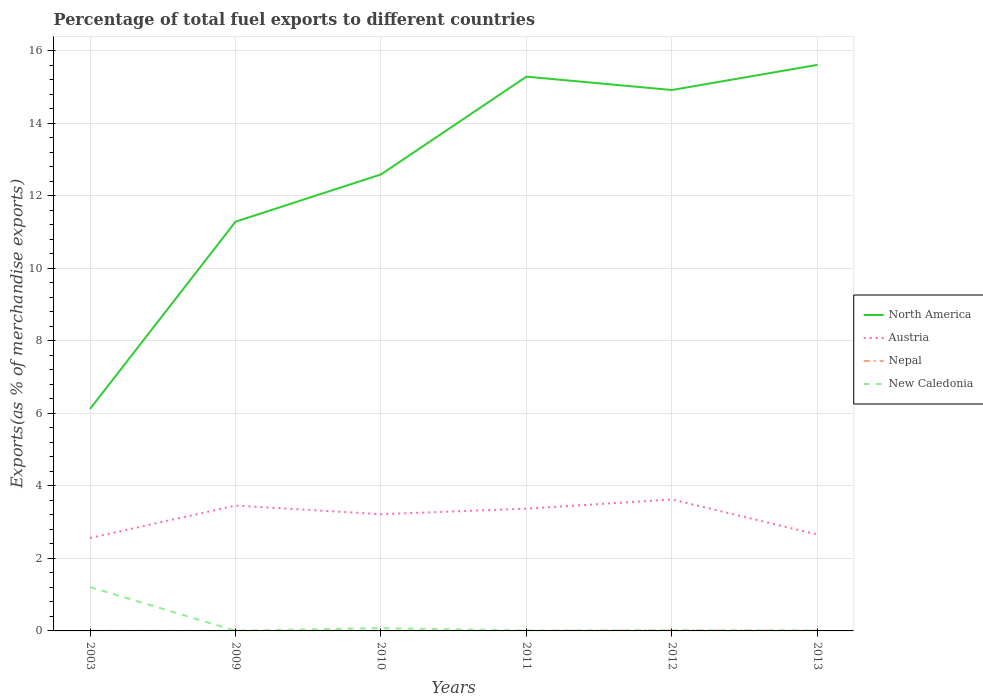How many different coloured lines are there?
Offer a terse response. 4. Across all years, what is the maximum percentage of exports to different countries in New Caledonia?
Provide a succinct answer. 0. What is the total percentage of exports to different countries in Nepal in the graph?
Give a very brief answer. -0. What is the difference between the highest and the second highest percentage of exports to different countries in Austria?
Keep it short and to the point. 1.06. What is the difference between the highest and the lowest percentage of exports to different countries in New Caledonia?
Ensure brevity in your answer.  1. Is the percentage of exports to different countries in New Caledonia strictly greater than the percentage of exports to different countries in North America over the years?
Your answer should be very brief. Yes. How many lines are there?
Keep it short and to the point. 4. How many years are there in the graph?
Give a very brief answer. 6. How many legend labels are there?
Provide a short and direct response. 4. How are the legend labels stacked?
Offer a very short reply. Vertical. What is the title of the graph?
Make the answer very short. Percentage of total fuel exports to different countries. Does "Switzerland" appear as one of the legend labels in the graph?
Your answer should be compact. No. What is the label or title of the Y-axis?
Your answer should be very brief. Exports(as % of merchandise exports). What is the Exports(as % of merchandise exports) in North America in 2003?
Your answer should be very brief. 6.12. What is the Exports(as % of merchandise exports) of Austria in 2003?
Keep it short and to the point. 2.56. What is the Exports(as % of merchandise exports) in Nepal in 2003?
Your response must be concise. 0. What is the Exports(as % of merchandise exports) in New Caledonia in 2003?
Keep it short and to the point. 1.21. What is the Exports(as % of merchandise exports) in North America in 2009?
Make the answer very short. 11.28. What is the Exports(as % of merchandise exports) of Austria in 2009?
Your answer should be very brief. 3.46. What is the Exports(as % of merchandise exports) in Nepal in 2009?
Provide a short and direct response. 0. What is the Exports(as % of merchandise exports) of New Caledonia in 2009?
Offer a very short reply. 0. What is the Exports(as % of merchandise exports) of North America in 2010?
Make the answer very short. 12.59. What is the Exports(as % of merchandise exports) of Austria in 2010?
Your answer should be very brief. 3.22. What is the Exports(as % of merchandise exports) of Nepal in 2010?
Ensure brevity in your answer.  4.5184108995034e-5. What is the Exports(as % of merchandise exports) in New Caledonia in 2010?
Your answer should be compact. 0.08. What is the Exports(as % of merchandise exports) in North America in 2011?
Your answer should be very brief. 15.28. What is the Exports(as % of merchandise exports) in Austria in 2011?
Make the answer very short. 3.37. What is the Exports(as % of merchandise exports) of Nepal in 2011?
Ensure brevity in your answer.  5.17830048737702e-6. What is the Exports(as % of merchandise exports) of New Caledonia in 2011?
Keep it short and to the point. 0.01. What is the Exports(as % of merchandise exports) in North America in 2012?
Keep it short and to the point. 14.92. What is the Exports(as % of merchandise exports) in Austria in 2012?
Your answer should be compact. 3.62. What is the Exports(as % of merchandise exports) of Nepal in 2012?
Your answer should be very brief. 0.01. What is the Exports(as % of merchandise exports) of New Caledonia in 2012?
Provide a short and direct response. 0.02. What is the Exports(as % of merchandise exports) of North America in 2013?
Ensure brevity in your answer.  15.61. What is the Exports(as % of merchandise exports) in Austria in 2013?
Offer a terse response. 2.66. What is the Exports(as % of merchandise exports) in Nepal in 2013?
Make the answer very short. 0. What is the Exports(as % of merchandise exports) in New Caledonia in 2013?
Make the answer very short. 0.01. Across all years, what is the maximum Exports(as % of merchandise exports) of North America?
Make the answer very short. 15.61. Across all years, what is the maximum Exports(as % of merchandise exports) in Austria?
Your response must be concise. 3.62. Across all years, what is the maximum Exports(as % of merchandise exports) in Nepal?
Keep it short and to the point. 0.01. Across all years, what is the maximum Exports(as % of merchandise exports) in New Caledonia?
Your answer should be compact. 1.21. Across all years, what is the minimum Exports(as % of merchandise exports) of North America?
Provide a succinct answer. 6.12. Across all years, what is the minimum Exports(as % of merchandise exports) in Austria?
Offer a very short reply. 2.56. Across all years, what is the minimum Exports(as % of merchandise exports) in Nepal?
Make the answer very short. 5.17830048737702e-6. Across all years, what is the minimum Exports(as % of merchandise exports) in New Caledonia?
Your answer should be compact. 0. What is the total Exports(as % of merchandise exports) of North America in the graph?
Your answer should be compact. 75.8. What is the total Exports(as % of merchandise exports) of Austria in the graph?
Your answer should be very brief. 18.89. What is the total Exports(as % of merchandise exports) of Nepal in the graph?
Provide a short and direct response. 0.02. What is the total Exports(as % of merchandise exports) in New Caledonia in the graph?
Make the answer very short. 1.33. What is the difference between the Exports(as % of merchandise exports) of North America in 2003 and that in 2009?
Provide a short and direct response. -5.16. What is the difference between the Exports(as % of merchandise exports) in Austria in 2003 and that in 2009?
Offer a very short reply. -0.89. What is the difference between the Exports(as % of merchandise exports) in Nepal in 2003 and that in 2009?
Offer a terse response. 0. What is the difference between the Exports(as % of merchandise exports) of New Caledonia in 2003 and that in 2009?
Your answer should be compact. 1.21. What is the difference between the Exports(as % of merchandise exports) of North America in 2003 and that in 2010?
Provide a short and direct response. -6.47. What is the difference between the Exports(as % of merchandise exports) in Austria in 2003 and that in 2010?
Your response must be concise. -0.66. What is the difference between the Exports(as % of merchandise exports) of Nepal in 2003 and that in 2010?
Your response must be concise. 0. What is the difference between the Exports(as % of merchandise exports) of New Caledonia in 2003 and that in 2010?
Provide a succinct answer. 1.13. What is the difference between the Exports(as % of merchandise exports) of North America in 2003 and that in 2011?
Offer a very short reply. -9.16. What is the difference between the Exports(as % of merchandise exports) of Austria in 2003 and that in 2011?
Your answer should be very brief. -0.81. What is the difference between the Exports(as % of merchandise exports) in Nepal in 2003 and that in 2011?
Your response must be concise. 0. What is the difference between the Exports(as % of merchandise exports) in New Caledonia in 2003 and that in 2011?
Keep it short and to the point. 1.2. What is the difference between the Exports(as % of merchandise exports) in North America in 2003 and that in 2012?
Offer a very short reply. -8.79. What is the difference between the Exports(as % of merchandise exports) in Austria in 2003 and that in 2012?
Your answer should be compact. -1.06. What is the difference between the Exports(as % of merchandise exports) of Nepal in 2003 and that in 2012?
Your response must be concise. -0.01. What is the difference between the Exports(as % of merchandise exports) in New Caledonia in 2003 and that in 2012?
Ensure brevity in your answer.  1.19. What is the difference between the Exports(as % of merchandise exports) of North America in 2003 and that in 2013?
Keep it short and to the point. -9.49. What is the difference between the Exports(as % of merchandise exports) of Austria in 2003 and that in 2013?
Make the answer very short. -0.1. What is the difference between the Exports(as % of merchandise exports) of Nepal in 2003 and that in 2013?
Your answer should be very brief. 0. What is the difference between the Exports(as % of merchandise exports) of New Caledonia in 2003 and that in 2013?
Your answer should be compact. 1.2. What is the difference between the Exports(as % of merchandise exports) of North America in 2009 and that in 2010?
Your answer should be very brief. -1.3. What is the difference between the Exports(as % of merchandise exports) in Austria in 2009 and that in 2010?
Give a very brief answer. 0.24. What is the difference between the Exports(as % of merchandise exports) in Nepal in 2009 and that in 2010?
Keep it short and to the point. 0. What is the difference between the Exports(as % of merchandise exports) of New Caledonia in 2009 and that in 2010?
Give a very brief answer. -0.07. What is the difference between the Exports(as % of merchandise exports) of North America in 2009 and that in 2011?
Offer a terse response. -4. What is the difference between the Exports(as % of merchandise exports) in Austria in 2009 and that in 2011?
Offer a terse response. 0.09. What is the difference between the Exports(as % of merchandise exports) of Nepal in 2009 and that in 2011?
Provide a succinct answer. 0. What is the difference between the Exports(as % of merchandise exports) in New Caledonia in 2009 and that in 2011?
Your response must be concise. -0.01. What is the difference between the Exports(as % of merchandise exports) of North America in 2009 and that in 2012?
Your answer should be compact. -3.63. What is the difference between the Exports(as % of merchandise exports) of Austria in 2009 and that in 2012?
Give a very brief answer. -0.17. What is the difference between the Exports(as % of merchandise exports) of Nepal in 2009 and that in 2012?
Offer a terse response. -0.01. What is the difference between the Exports(as % of merchandise exports) in New Caledonia in 2009 and that in 2012?
Provide a succinct answer. -0.01. What is the difference between the Exports(as % of merchandise exports) in North America in 2009 and that in 2013?
Keep it short and to the point. -4.32. What is the difference between the Exports(as % of merchandise exports) in Austria in 2009 and that in 2013?
Your response must be concise. 0.8. What is the difference between the Exports(as % of merchandise exports) of Nepal in 2009 and that in 2013?
Offer a terse response. -0. What is the difference between the Exports(as % of merchandise exports) of New Caledonia in 2009 and that in 2013?
Make the answer very short. -0.01. What is the difference between the Exports(as % of merchandise exports) in North America in 2010 and that in 2011?
Offer a terse response. -2.7. What is the difference between the Exports(as % of merchandise exports) of Austria in 2010 and that in 2011?
Provide a short and direct response. -0.15. What is the difference between the Exports(as % of merchandise exports) of New Caledonia in 2010 and that in 2011?
Your answer should be compact. 0.07. What is the difference between the Exports(as % of merchandise exports) of North America in 2010 and that in 2012?
Provide a short and direct response. -2.33. What is the difference between the Exports(as % of merchandise exports) in Austria in 2010 and that in 2012?
Offer a terse response. -0.41. What is the difference between the Exports(as % of merchandise exports) of Nepal in 2010 and that in 2012?
Provide a short and direct response. -0.01. What is the difference between the Exports(as % of merchandise exports) of New Caledonia in 2010 and that in 2012?
Provide a succinct answer. 0.06. What is the difference between the Exports(as % of merchandise exports) in North America in 2010 and that in 2013?
Your answer should be compact. -3.02. What is the difference between the Exports(as % of merchandise exports) of Austria in 2010 and that in 2013?
Offer a terse response. 0.56. What is the difference between the Exports(as % of merchandise exports) of Nepal in 2010 and that in 2013?
Ensure brevity in your answer.  -0. What is the difference between the Exports(as % of merchandise exports) in New Caledonia in 2010 and that in 2013?
Keep it short and to the point. 0.06. What is the difference between the Exports(as % of merchandise exports) in North America in 2011 and that in 2012?
Offer a terse response. 0.37. What is the difference between the Exports(as % of merchandise exports) in Austria in 2011 and that in 2012?
Your response must be concise. -0.25. What is the difference between the Exports(as % of merchandise exports) of Nepal in 2011 and that in 2012?
Make the answer very short. -0.01. What is the difference between the Exports(as % of merchandise exports) in New Caledonia in 2011 and that in 2012?
Offer a very short reply. -0. What is the difference between the Exports(as % of merchandise exports) of North America in 2011 and that in 2013?
Your response must be concise. -0.32. What is the difference between the Exports(as % of merchandise exports) of Austria in 2011 and that in 2013?
Your answer should be compact. 0.71. What is the difference between the Exports(as % of merchandise exports) in Nepal in 2011 and that in 2013?
Your answer should be very brief. -0. What is the difference between the Exports(as % of merchandise exports) of New Caledonia in 2011 and that in 2013?
Provide a short and direct response. -0. What is the difference between the Exports(as % of merchandise exports) in North America in 2012 and that in 2013?
Make the answer very short. -0.69. What is the difference between the Exports(as % of merchandise exports) of Austria in 2012 and that in 2013?
Keep it short and to the point. 0.97. What is the difference between the Exports(as % of merchandise exports) of Nepal in 2012 and that in 2013?
Keep it short and to the point. 0.01. What is the difference between the Exports(as % of merchandise exports) in New Caledonia in 2012 and that in 2013?
Keep it short and to the point. 0. What is the difference between the Exports(as % of merchandise exports) in North America in 2003 and the Exports(as % of merchandise exports) in Austria in 2009?
Your answer should be very brief. 2.67. What is the difference between the Exports(as % of merchandise exports) of North America in 2003 and the Exports(as % of merchandise exports) of Nepal in 2009?
Your answer should be very brief. 6.12. What is the difference between the Exports(as % of merchandise exports) in North America in 2003 and the Exports(as % of merchandise exports) in New Caledonia in 2009?
Offer a very short reply. 6.12. What is the difference between the Exports(as % of merchandise exports) of Austria in 2003 and the Exports(as % of merchandise exports) of Nepal in 2009?
Offer a terse response. 2.56. What is the difference between the Exports(as % of merchandise exports) in Austria in 2003 and the Exports(as % of merchandise exports) in New Caledonia in 2009?
Your response must be concise. 2.56. What is the difference between the Exports(as % of merchandise exports) of Nepal in 2003 and the Exports(as % of merchandise exports) of New Caledonia in 2009?
Your response must be concise. -0. What is the difference between the Exports(as % of merchandise exports) in North America in 2003 and the Exports(as % of merchandise exports) in Austria in 2010?
Give a very brief answer. 2.9. What is the difference between the Exports(as % of merchandise exports) of North America in 2003 and the Exports(as % of merchandise exports) of Nepal in 2010?
Offer a terse response. 6.12. What is the difference between the Exports(as % of merchandise exports) of North America in 2003 and the Exports(as % of merchandise exports) of New Caledonia in 2010?
Offer a very short reply. 6.05. What is the difference between the Exports(as % of merchandise exports) in Austria in 2003 and the Exports(as % of merchandise exports) in Nepal in 2010?
Provide a short and direct response. 2.56. What is the difference between the Exports(as % of merchandise exports) in Austria in 2003 and the Exports(as % of merchandise exports) in New Caledonia in 2010?
Keep it short and to the point. 2.49. What is the difference between the Exports(as % of merchandise exports) in Nepal in 2003 and the Exports(as % of merchandise exports) in New Caledonia in 2010?
Offer a terse response. -0.07. What is the difference between the Exports(as % of merchandise exports) of North America in 2003 and the Exports(as % of merchandise exports) of Austria in 2011?
Make the answer very short. 2.75. What is the difference between the Exports(as % of merchandise exports) in North America in 2003 and the Exports(as % of merchandise exports) in Nepal in 2011?
Offer a very short reply. 6.12. What is the difference between the Exports(as % of merchandise exports) of North America in 2003 and the Exports(as % of merchandise exports) of New Caledonia in 2011?
Provide a short and direct response. 6.11. What is the difference between the Exports(as % of merchandise exports) in Austria in 2003 and the Exports(as % of merchandise exports) in Nepal in 2011?
Offer a terse response. 2.56. What is the difference between the Exports(as % of merchandise exports) of Austria in 2003 and the Exports(as % of merchandise exports) of New Caledonia in 2011?
Ensure brevity in your answer.  2.55. What is the difference between the Exports(as % of merchandise exports) of Nepal in 2003 and the Exports(as % of merchandise exports) of New Caledonia in 2011?
Give a very brief answer. -0.01. What is the difference between the Exports(as % of merchandise exports) of North America in 2003 and the Exports(as % of merchandise exports) of Austria in 2012?
Ensure brevity in your answer.  2.5. What is the difference between the Exports(as % of merchandise exports) of North America in 2003 and the Exports(as % of merchandise exports) of Nepal in 2012?
Offer a terse response. 6.11. What is the difference between the Exports(as % of merchandise exports) of North America in 2003 and the Exports(as % of merchandise exports) of New Caledonia in 2012?
Keep it short and to the point. 6.11. What is the difference between the Exports(as % of merchandise exports) of Austria in 2003 and the Exports(as % of merchandise exports) of Nepal in 2012?
Offer a terse response. 2.55. What is the difference between the Exports(as % of merchandise exports) of Austria in 2003 and the Exports(as % of merchandise exports) of New Caledonia in 2012?
Make the answer very short. 2.55. What is the difference between the Exports(as % of merchandise exports) in Nepal in 2003 and the Exports(as % of merchandise exports) in New Caledonia in 2012?
Make the answer very short. -0.01. What is the difference between the Exports(as % of merchandise exports) in North America in 2003 and the Exports(as % of merchandise exports) in Austria in 2013?
Make the answer very short. 3.46. What is the difference between the Exports(as % of merchandise exports) in North America in 2003 and the Exports(as % of merchandise exports) in Nepal in 2013?
Give a very brief answer. 6.12. What is the difference between the Exports(as % of merchandise exports) in North America in 2003 and the Exports(as % of merchandise exports) in New Caledonia in 2013?
Your answer should be very brief. 6.11. What is the difference between the Exports(as % of merchandise exports) of Austria in 2003 and the Exports(as % of merchandise exports) of Nepal in 2013?
Offer a terse response. 2.56. What is the difference between the Exports(as % of merchandise exports) of Austria in 2003 and the Exports(as % of merchandise exports) of New Caledonia in 2013?
Offer a very short reply. 2.55. What is the difference between the Exports(as % of merchandise exports) in Nepal in 2003 and the Exports(as % of merchandise exports) in New Caledonia in 2013?
Your answer should be compact. -0.01. What is the difference between the Exports(as % of merchandise exports) of North America in 2009 and the Exports(as % of merchandise exports) of Austria in 2010?
Provide a short and direct response. 8.07. What is the difference between the Exports(as % of merchandise exports) in North America in 2009 and the Exports(as % of merchandise exports) in Nepal in 2010?
Give a very brief answer. 11.28. What is the difference between the Exports(as % of merchandise exports) in North America in 2009 and the Exports(as % of merchandise exports) in New Caledonia in 2010?
Offer a very short reply. 11.21. What is the difference between the Exports(as % of merchandise exports) of Austria in 2009 and the Exports(as % of merchandise exports) of Nepal in 2010?
Your response must be concise. 3.46. What is the difference between the Exports(as % of merchandise exports) of Austria in 2009 and the Exports(as % of merchandise exports) of New Caledonia in 2010?
Give a very brief answer. 3.38. What is the difference between the Exports(as % of merchandise exports) of Nepal in 2009 and the Exports(as % of merchandise exports) of New Caledonia in 2010?
Provide a succinct answer. -0.07. What is the difference between the Exports(as % of merchandise exports) in North America in 2009 and the Exports(as % of merchandise exports) in Austria in 2011?
Give a very brief answer. 7.91. What is the difference between the Exports(as % of merchandise exports) of North America in 2009 and the Exports(as % of merchandise exports) of Nepal in 2011?
Make the answer very short. 11.28. What is the difference between the Exports(as % of merchandise exports) in North America in 2009 and the Exports(as % of merchandise exports) in New Caledonia in 2011?
Provide a succinct answer. 11.27. What is the difference between the Exports(as % of merchandise exports) in Austria in 2009 and the Exports(as % of merchandise exports) in Nepal in 2011?
Your answer should be very brief. 3.46. What is the difference between the Exports(as % of merchandise exports) in Austria in 2009 and the Exports(as % of merchandise exports) in New Caledonia in 2011?
Ensure brevity in your answer.  3.45. What is the difference between the Exports(as % of merchandise exports) in Nepal in 2009 and the Exports(as % of merchandise exports) in New Caledonia in 2011?
Offer a terse response. -0.01. What is the difference between the Exports(as % of merchandise exports) in North America in 2009 and the Exports(as % of merchandise exports) in Austria in 2012?
Keep it short and to the point. 7.66. What is the difference between the Exports(as % of merchandise exports) of North America in 2009 and the Exports(as % of merchandise exports) of Nepal in 2012?
Offer a terse response. 11.27. What is the difference between the Exports(as % of merchandise exports) of North America in 2009 and the Exports(as % of merchandise exports) of New Caledonia in 2012?
Offer a very short reply. 11.27. What is the difference between the Exports(as % of merchandise exports) of Austria in 2009 and the Exports(as % of merchandise exports) of Nepal in 2012?
Provide a short and direct response. 3.44. What is the difference between the Exports(as % of merchandise exports) of Austria in 2009 and the Exports(as % of merchandise exports) of New Caledonia in 2012?
Make the answer very short. 3.44. What is the difference between the Exports(as % of merchandise exports) in Nepal in 2009 and the Exports(as % of merchandise exports) in New Caledonia in 2012?
Provide a short and direct response. -0.01. What is the difference between the Exports(as % of merchandise exports) in North America in 2009 and the Exports(as % of merchandise exports) in Austria in 2013?
Your response must be concise. 8.63. What is the difference between the Exports(as % of merchandise exports) of North America in 2009 and the Exports(as % of merchandise exports) of Nepal in 2013?
Give a very brief answer. 11.28. What is the difference between the Exports(as % of merchandise exports) in North America in 2009 and the Exports(as % of merchandise exports) in New Caledonia in 2013?
Your answer should be compact. 11.27. What is the difference between the Exports(as % of merchandise exports) in Austria in 2009 and the Exports(as % of merchandise exports) in Nepal in 2013?
Give a very brief answer. 3.45. What is the difference between the Exports(as % of merchandise exports) in Austria in 2009 and the Exports(as % of merchandise exports) in New Caledonia in 2013?
Make the answer very short. 3.44. What is the difference between the Exports(as % of merchandise exports) of Nepal in 2009 and the Exports(as % of merchandise exports) of New Caledonia in 2013?
Offer a very short reply. -0.01. What is the difference between the Exports(as % of merchandise exports) in North America in 2010 and the Exports(as % of merchandise exports) in Austria in 2011?
Offer a terse response. 9.22. What is the difference between the Exports(as % of merchandise exports) in North America in 2010 and the Exports(as % of merchandise exports) in Nepal in 2011?
Your response must be concise. 12.59. What is the difference between the Exports(as % of merchandise exports) in North America in 2010 and the Exports(as % of merchandise exports) in New Caledonia in 2011?
Ensure brevity in your answer.  12.58. What is the difference between the Exports(as % of merchandise exports) in Austria in 2010 and the Exports(as % of merchandise exports) in Nepal in 2011?
Provide a short and direct response. 3.22. What is the difference between the Exports(as % of merchandise exports) in Austria in 2010 and the Exports(as % of merchandise exports) in New Caledonia in 2011?
Provide a short and direct response. 3.21. What is the difference between the Exports(as % of merchandise exports) of Nepal in 2010 and the Exports(as % of merchandise exports) of New Caledonia in 2011?
Give a very brief answer. -0.01. What is the difference between the Exports(as % of merchandise exports) of North America in 2010 and the Exports(as % of merchandise exports) of Austria in 2012?
Your answer should be very brief. 8.96. What is the difference between the Exports(as % of merchandise exports) of North America in 2010 and the Exports(as % of merchandise exports) of Nepal in 2012?
Offer a very short reply. 12.58. What is the difference between the Exports(as % of merchandise exports) of North America in 2010 and the Exports(as % of merchandise exports) of New Caledonia in 2012?
Provide a succinct answer. 12.57. What is the difference between the Exports(as % of merchandise exports) of Austria in 2010 and the Exports(as % of merchandise exports) of Nepal in 2012?
Give a very brief answer. 3.21. What is the difference between the Exports(as % of merchandise exports) in Austria in 2010 and the Exports(as % of merchandise exports) in New Caledonia in 2012?
Provide a succinct answer. 3.2. What is the difference between the Exports(as % of merchandise exports) of Nepal in 2010 and the Exports(as % of merchandise exports) of New Caledonia in 2012?
Provide a succinct answer. -0.02. What is the difference between the Exports(as % of merchandise exports) in North America in 2010 and the Exports(as % of merchandise exports) in Austria in 2013?
Keep it short and to the point. 9.93. What is the difference between the Exports(as % of merchandise exports) of North America in 2010 and the Exports(as % of merchandise exports) of Nepal in 2013?
Your answer should be very brief. 12.58. What is the difference between the Exports(as % of merchandise exports) in North America in 2010 and the Exports(as % of merchandise exports) in New Caledonia in 2013?
Ensure brevity in your answer.  12.57. What is the difference between the Exports(as % of merchandise exports) of Austria in 2010 and the Exports(as % of merchandise exports) of Nepal in 2013?
Provide a short and direct response. 3.22. What is the difference between the Exports(as % of merchandise exports) in Austria in 2010 and the Exports(as % of merchandise exports) in New Caledonia in 2013?
Provide a succinct answer. 3.2. What is the difference between the Exports(as % of merchandise exports) in Nepal in 2010 and the Exports(as % of merchandise exports) in New Caledonia in 2013?
Your answer should be compact. -0.01. What is the difference between the Exports(as % of merchandise exports) in North America in 2011 and the Exports(as % of merchandise exports) in Austria in 2012?
Make the answer very short. 11.66. What is the difference between the Exports(as % of merchandise exports) in North America in 2011 and the Exports(as % of merchandise exports) in Nepal in 2012?
Provide a succinct answer. 15.27. What is the difference between the Exports(as % of merchandise exports) in North America in 2011 and the Exports(as % of merchandise exports) in New Caledonia in 2012?
Ensure brevity in your answer.  15.27. What is the difference between the Exports(as % of merchandise exports) in Austria in 2011 and the Exports(as % of merchandise exports) in Nepal in 2012?
Provide a short and direct response. 3.36. What is the difference between the Exports(as % of merchandise exports) of Austria in 2011 and the Exports(as % of merchandise exports) of New Caledonia in 2012?
Make the answer very short. 3.36. What is the difference between the Exports(as % of merchandise exports) in Nepal in 2011 and the Exports(as % of merchandise exports) in New Caledonia in 2012?
Ensure brevity in your answer.  -0.02. What is the difference between the Exports(as % of merchandise exports) in North America in 2011 and the Exports(as % of merchandise exports) in Austria in 2013?
Your response must be concise. 12.63. What is the difference between the Exports(as % of merchandise exports) in North America in 2011 and the Exports(as % of merchandise exports) in Nepal in 2013?
Give a very brief answer. 15.28. What is the difference between the Exports(as % of merchandise exports) of North America in 2011 and the Exports(as % of merchandise exports) of New Caledonia in 2013?
Ensure brevity in your answer.  15.27. What is the difference between the Exports(as % of merchandise exports) in Austria in 2011 and the Exports(as % of merchandise exports) in Nepal in 2013?
Keep it short and to the point. 3.37. What is the difference between the Exports(as % of merchandise exports) in Austria in 2011 and the Exports(as % of merchandise exports) in New Caledonia in 2013?
Keep it short and to the point. 3.36. What is the difference between the Exports(as % of merchandise exports) in Nepal in 2011 and the Exports(as % of merchandise exports) in New Caledonia in 2013?
Ensure brevity in your answer.  -0.01. What is the difference between the Exports(as % of merchandise exports) of North America in 2012 and the Exports(as % of merchandise exports) of Austria in 2013?
Provide a short and direct response. 12.26. What is the difference between the Exports(as % of merchandise exports) of North America in 2012 and the Exports(as % of merchandise exports) of Nepal in 2013?
Give a very brief answer. 14.91. What is the difference between the Exports(as % of merchandise exports) of North America in 2012 and the Exports(as % of merchandise exports) of New Caledonia in 2013?
Provide a succinct answer. 14.9. What is the difference between the Exports(as % of merchandise exports) in Austria in 2012 and the Exports(as % of merchandise exports) in Nepal in 2013?
Your answer should be very brief. 3.62. What is the difference between the Exports(as % of merchandise exports) in Austria in 2012 and the Exports(as % of merchandise exports) in New Caledonia in 2013?
Ensure brevity in your answer.  3.61. What is the difference between the Exports(as % of merchandise exports) of Nepal in 2012 and the Exports(as % of merchandise exports) of New Caledonia in 2013?
Ensure brevity in your answer.  -0. What is the average Exports(as % of merchandise exports) of North America per year?
Keep it short and to the point. 12.63. What is the average Exports(as % of merchandise exports) of Austria per year?
Make the answer very short. 3.15. What is the average Exports(as % of merchandise exports) of Nepal per year?
Give a very brief answer. 0. What is the average Exports(as % of merchandise exports) in New Caledonia per year?
Offer a very short reply. 0.22. In the year 2003, what is the difference between the Exports(as % of merchandise exports) in North America and Exports(as % of merchandise exports) in Austria?
Keep it short and to the point. 3.56. In the year 2003, what is the difference between the Exports(as % of merchandise exports) in North America and Exports(as % of merchandise exports) in Nepal?
Your response must be concise. 6.12. In the year 2003, what is the difference between the Exports(as % of merchandise exports) in North America and Exports(as % of merchandise exports) in New Caledonia?
Offer a terse response. 4.91. In the year 2003, what is the difference between the Exports(as % of merchandise exports) in Austria and Exports(as % of merchandise exports) in Nepal?
Offer a very short reply. 2.56. In the year 2003, what is the difference between the Exports(as % of merchandise exports) of Austria and Exports(as % of merchandise exports) of New Caledonia?
Your response must be concise. 1.35. In the year 2003, what is the difference between the Exports(as % of merchandise exports) of Nepal and Exports(as % of merchandise exports) of New Caledonia?
Offer a very short reply. -1.21. In the year 2009, what is the difference between the Exports(as % of merchandise exports) of North America and Exports(as % of merchandise exports) of Austria?
Your response must be concise. 7.83. In the year 2009, what is the difference between the Exports(as % of merchandise exports) in North America and Exports(as % of merchandise exports) in Nepal?
Your response must be concise. 11.28. In the year 2009, what is the difference between the Exports(as % of merchandise exports) of North America and Exports(as % of merchandise exports) of New Caledonia?
Your response must be concise. 11.28. In the year 2009, what is the difference between the Exports(as % of merchandise exports) of Austria and Exports(as % of merchandise exports) of Nepal?
Give a very brief answer. 3.45. In the year 2009, what is the difference between the Exports(as % of merchandise exports) of Austria and Exports(as % of merchandise exports) of New Caledonia?
Provide a short and direct response. 3.45. In the year 2009, what is the difference between the Exports(as % of merchandise exports) of Nepal and Exports(as % of merchandise exports) of New Caledonia?
Your answer should be compact. -0. In the year 2010, what is the difference between the Exports(as % of merchandise exports) of North America and Exports(as % of merchandise exports) of Austria?
Your answer should be compact. 9.37. In the year 2010, what is the difference between the Exports(as % of merchandise exports) of North America and Exports(as % of merchandise exports) of Nepal?
Your response must be concise. 12.59. In the year 2010, what is the difference between the Exports(as % of merchandise exports) in North America and Exports(as % of merchandise exports) in New Caledonia?
Your answer should be compact. 12.51. In the year 2010, what is the difference between the Exports(as % of merchandise exports) of Austria and Exports(as % of merchandise exports) of Nepal?
Provide a short and direct response. 3.22. In the year 2010, what is the difference between the Exports(as % of merchandise exports) of Austria and Exports(as % of merchandise exports) of New Caledonia?
Provide a succinct answer. 3.14. In the year 2010, what is the difference between the Exports(as % of merchandise exports) of Nepal and Exports(as % of merchandise exports) of New Caledonia?
Make the answer very short. -0.08. In the year 2011, what is the difference between the Exports(as % of merchandise exports) in North America and Exports(as % of merchandise exports) in Austria?
Offer a terse response. 11.91. In the year 2011, what is the difference between the Exports(as % of merchandise exports) in North America and Exports(as % of merchandise exports) in Nepal?
Offer a terse response. 15.28. In the year 2011, what is the difference between the Exports(as % of merchandise exports) in North America and Exports(as % of merchandise exports) in New Caledonia?
Provide a short and direct response. 15.27. In the year 2011, what is the difference between the Exports(as % of merchandise exports) in Austria and Exports(as % of merchandise exports) in Nepal?
Offer a very short reply. 3.37. In the year 2011, what is the difference between the Exports(as % of merchandise exports) of Austria and Exports(as % of merchandise exports) of New Caledonia?
Give a very brief answer. 3.36. In the year 2011, what is the difference between the Exports(as % of merchandise exports) of Nepal and Exports(as % of merchandise exports) of New Caledonia?
Your answer should be very brief. -0.01. In the year 2012, what is the difference between the Exports(as % of merchandise exports) in North America and Exports(as % of merchandise exports) in Austria?
Provide a succinct answer. 11.29. In the year 2012, what is the difference between the Exports(as % of merchandise exports) in North America and Exports(as % of merchandise exports) in Nepal?
Provide a succinct answer. 14.9. In the year 2012, what is the difference between the Exports(as % of merchandise exports) of North America and Exports(as % of merchandise exports) of New Caledonia?
Provide a succinct answer. 14.9. In the year 2012, what is the difference between the Exports(as % of merchandise exports) of Austria and Exports(as % of merchandise exports) of Nepal?
Provide a succinct answer. 3.61. In the year 2012, what is the difference between the Exports(as % of merchandise exports) of Austria and Exports(as % of merchandise exports) of New Caledonia?
Your response must be concise. 3.61. In the year 2012, what is the difference between the Exports(as % of merchandise exports) of Nepal and Exports(as % of merchandise exports) of New Caledonia?
Provide a short and direct response. -0. In the year 2013, what is the difference between the Exports(as % of merchandise exports) in North America and Exports(as % of merchandise exports) in Austria?
Your response must be concise. 12.95. In the year 2013, what is the difference between the Exports(as % of merchandise exports) of North America and Exports(as % of merchandise exports) of Nepal?
Make the answer very short. 15.61. In the year 2013, what is the difference between the Exports(as % of merchandise exports) in North America and Exports(as % of merchandise exports) in New Caledonia?
Give a very brief answer. 15.59. In the year 2013, what is the difference between the Exports(as % of merchandise exports) of Austria and Exports(as % of merchandise exports) of Nepal?
Offer a terse response. 2.66. In the year 2013, what is the difference between the Exports(as % of merchandise exports) of Austria and Exports(as % of merchandise exports) of New Caledonia?
Keep it short and to the point. 2.64. In the year 2013, what is the difference between the Exports(as % of merchandise exports) of Nepal and Exports(as % of merchandise exports) of New Caledonia?
Keep it short and to the point. -0.01. What is the ratio of the Exports(as % of merchandise exports) of North America in 2003 to that in 2009?
Provide a short and direct response. 0.54. What is the ratio of the Exports(as % of merchandise exports) of Austria in 2003 to that in 2009?
Keep it short and to the point. 0.74. What is the ratio of the Exports(as % of merchandise exports) of Nepal in 2003 to that in 2009?
Provide a succinct answer. 2.12. What is the ratio of the Exports(as % of merchandise exports) in New Caledonia in 2003 to that in 2009?
Provide a short and direct response. 248.02. What is the ratio of the Exports(as % of merchandise exports) in North America in 2003 to that in 2010?
Keep it short and to the point. 0.49. What is the ratio of the Exports(as % of merchandise exports) of Austria in 2003 to that in 2010?
Provide a short and direct response. 0.8. What is the ratio of the Exports(as % of merchandise exports) of Nepal in 2003 to that in 2010?
Offer a very short reply. 79.14. What is the ratio of the Exports(as % of merchandise exports) in New Caledonia in 2003 to that in 2010?
Offer a very short reply. 15.87. What is the ratio of the Exports(as % of merchandise exports) of North America in 2003 to that in 2011?
Offer a terse response. 0.4. What is the ratio of the Exports(as % of merchandise exports) in Austria in 2003 to that in 2011?
Provide a succinct answer. 0.76. What is the ratio of the Exports(as % of merchandise exports) in Nepal in 2003 to that in 2011?
Provide a succinct answer. 690.53. What is the ratio of the Exports(as % of merchandise exports) of New Caledonia in 2003 to that in 2011?
Provide a succinct answer. 115.56. What is the ratio of the Exports(as % of merchandise exports) in North America in 2003 to that in 2012?
Make the answer very short. 0.41. What is the ratio of the Exports(as % of merchandise exports) in Austria in 2003 to that in 2012?
Your answer should be very brief. 0.71. What is the ratio of the Exports(as % of merchandise exports) of Nepal in 2003 to that in 2012?
Your answer should be compact. 0.28. What is the ratio of the Exports(as % of merchandise exports) of New Caledonia in 2003 to that in 2012?
Your response must be concise. 79.58. What is the ratio of the Exports(as % of merchandise exports) of North America in 2003 to that in 2013?
Provide a succinct answer. 0.39. What is the ratio of the Exports(as % of merchandise exports) in Austria in 2003 to that in 2013?
Offer a very short reply. 0.96. What is the ratio of the Exports(as % of merchandise exports) of Nepal in 2003 to that in 2013?
Your answer should be very brief. 1.13. What is the ratio of the Exports(as % of merchandise exports) of New Caledonia in 2003 to that in 2013?
Keep it short and to the point. 81.88. What is the ratio of the Exports(as % of merchandise exports) of North America in 2009 to that in 2010?
Ensure brevity in your answer.  0.9. What is the ratio of the Exports(as % of merchandise exports) of Austria in 2009 to that in 2010?
Provide a succinct answer. 1.07. What is the ratio of the Exports(as % of merchandise exports) in Nepal in 2009 to that in 2010?
Provide a succinct answer. 37.35. What is the ratio of the Exports(as % of merchandise exports) of New Caledonia in 2009 to that in 2010?
Provide a succinct answer. 0.06. What is the ratio of the Exports(as % of merchandise exports) of North America in 2009 to that in 2011?
Offer a terse response. 0.74. What is the ratio of the Exports(as % of merchandise exports) in Austria in 2009 to that in 2011?
Offer a terse response. 1.03. What is the ratio of the Exports(as % of merchandise exports) in Nepal in 2009 to that in 2011?
Offer a terse response. 325.88. What is the ratio of the Exports(as % of merchandise exports) of New Caledonia in 2009 to that in 2011?
Provide a short and direct response. 0.47. What is the ratio of the Exports(as % of merchandise exports) in North America in 2009 to that in 2012?
Make the answer very short. 0.76. What is the ratio of the Exports(as % of merchandise exports) in Austria in 2009 to that in 2012?
Make the answer very short. 0.95. What is the ratio of the Exports(as % of merchandise exports) in Nepal in 2009 to that in 2012?
Your answer should be compact. 0.13. What is the ratio of the Exports(as % of merchandise exports) in New Caledonia in 2009 to that in 2012?
Provide a succinct answer. 0.32. What is the ratio of the Exports(as % of merchandise exports) of North America in 2009 to that in 2013?
Ensure brevity in your answer.  0.72. What is the ratio of the Exports(as % of merchandise exports) in Austria in 2009 to that in 2013?
Make the answer very short. 1.3. What is the ratio of the Exports(as % of merchandise exports) in Nepal in 2009 to that in 2013?
Provide a short and direct response. 0.53. What is the ratio of the Exports(as % of merchandise exports) in New Caledonia in 2009 to that in 2013?
Keep it short and to the point. 0.33. What is the ratio of the Exports(as % of merchandise exports) of North America in 2010 to that in 2011?
Your answer should be compact. 0.82. What is the ratio of the Exports(as % of merchandise exports) in Austria in 2010 to that in 2011?
Offer a very short reply. 0.95. What is the ratio of the Exports(as % of merchandise exports) in Nepal in 2010 to that in 2011?
Your answer should be very brief. 8.73. What is the ratio of the Exports(as % of merchandise exports) in New Caledonia in 2010 to that in 2011?
Offer a terse response. 7.28. What is the ratio of the Exports(as % of merchandise exports) of North America in 2010 to that in 2012?
Your answer should be compact. 0.84. What is the ratio of the Exports(as % of merchandise exports) of Austria in 2010 to that in 2012?
Offer a terse response. 0.89. What is the ratio of the Exports(as % of merchandise exports) in Nepal in 2010 to that in 2012?
Provide a short and direct response. 0. What is the ratio of the Exports(as % of merchandise exports) in New Caledonia in 2010 to that in 2012?
Ensure brevity in your answer.  5.02. What is the ratio of the Exports(as % of merchandise exports) of North America in 2010 to that in 2013?
Offer a very short reply. 0.81. What is the ratio of the Exports(as % of merchandise exports) of Austria in 2010 to that in 2013?
Make the answer very short. 1.21. What is the ratio of the Exports(as % of merchandise exports) of Nepal in 2010 to that in 2013?
Give a very brief answer. 0.01. What is the ratio of the Exports(as % of merchandise exports) in New Caledonia in 2010 to that in 2013?
Provide a succinct answer. 5.16. What is the ratio of the Exports(as % of merchandise exports) in North America in 2011 to that in 2012?
Your response must be concise. 1.02. What is the ratio of the Exports(as % of merchandise exports) in Austria in 2011 to that in 2012?
Your answer should be very brief. 0.93. What is the ratio of the Exports(as % of merchandise exports) of New Caledonia in 2011 to that in 2012?
Provide a succinct answer. 0.69. What is the ratio of the Exports(as % of merchandise exports) of North America in 2011 to that in 2013?
Your answer should be compact. 0.98. What is the ratio of the Exports(as % of merchandise exports) in Austria in 2011 to that in 2013?
Provide a short and direct response. 1.27. What is the ratio of the Exports(as % of merchandise exports) in Nepal in 2011 to that in 2013?
Your answer should be compact. 0. What is the ratio of the Exports(as % of merchandise exports) in New Caledonia in 2011 to that in 2013?
Give a very brief answer. 0.71. What is the ratio of the Exports(as % of merchandise exports) in North America in 2012 to that in 2013?
Your answer should be very brief. 0.96. What is the ratio of the Exports(as % of merchandise exports) of Austria in 2012 to that in 2013?
Keep it short and to the point. 1.36. What is the ratio of the Exports(as % of merchandise exports) of Nepal in 2012 to that in 2013?
Your response must be concise. 4.02. What is the ratio of the Exports(as % of merchandise exports) of New Caledonia in 2012 to that in 2013?
Keep it short and to the point. 1.03. What is the difference between the highest and the second highest Exports(as % of merchandise exports) of North America?
Keep it short and to the point. 0.32. What is the difference between the highest and the second highest Exports(as % of merchandise exports) in Austria?
Your answer should be compact. 0.17. What is the difference between the highest and the second highest Exports(as % of merchandise exports) in Nepal?
Offer a very short reply. 0.01. What is the difference between the highest and the second highest Exports(as % of merchandise exports) in New Caledonia?
Your answer should be very brief. 1.13. What is the difference between the highest and the lowest Exports(as % of merchandise exports) of North America?
Provide a short and direct response. 9.49. What is the difference between the highest and the lowest Exports(as % of merchandise exports) of Austria?
Offer a terse response. 1.06. What is the difference between the highest and the lowest Exports(as % of merchandise exports) of Nepal?
Make the answer very short. 0.01. What is the difference between the highest and the lowest Exports(as % of merchandise exports) of New Caledonia?
Keep it short and to the point. 1.21. 